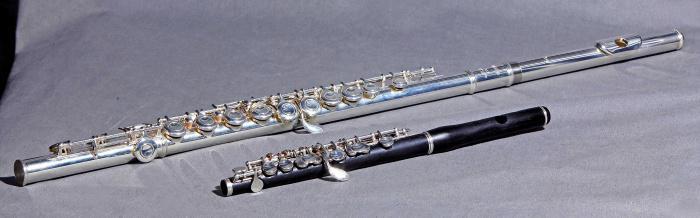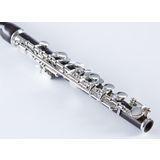The first image is the image on the left, the second image is the image on the right. Analyze the images presented: Is the assertion "There are exactly two instruments in total." valid? Answer yes or no. No. The first image is the image on the left, the second image is the image on the right. For the images shown, is this caption "The left image contains twice as many flutes as the right image." true? Answer yes or no. Yes. 